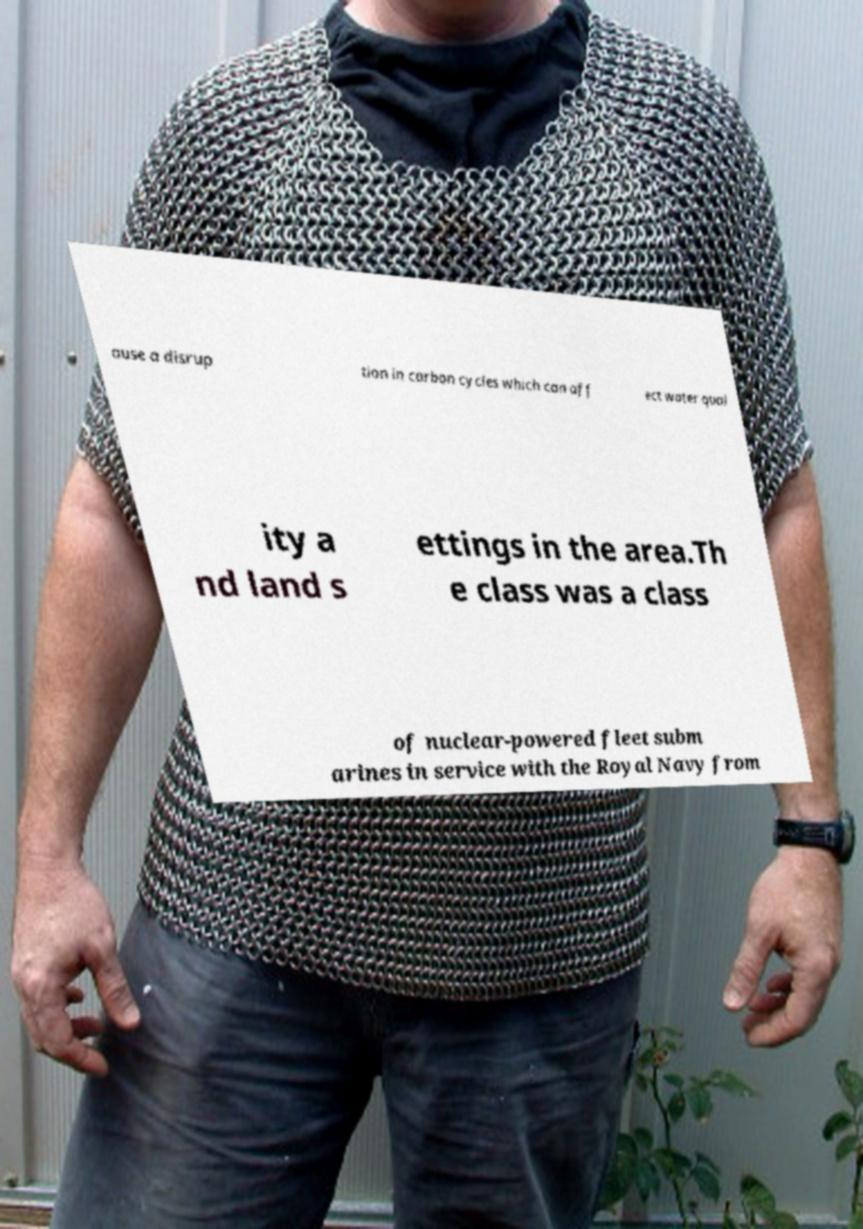Please identify and transcribe the text found in this image. ause a disrup tion in carbon cycles which can aff ect water qual ity a nd land s ettings in the area.Th e class was a class of nuclear-powered fleet subm arines in service with the Royal Navy from 